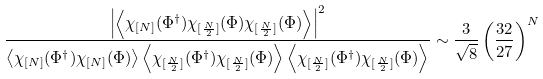<formula> <loc_0><loc_0><loc_500><loc_500>\frac { \left | \left \langle \chi _ { [ N ] } ( \Phi ^ { \dagger } ) \chi _ { [ \frac { N } { 2 } ] } ( \Phi ) \chi _ { [ \frac { N } { 2 } ] } ( \Phi ) \right \rangle \right | ^ { 2 } } { \left \langle \chi _ { [ N ] } ( \Phi ^ { \dagger } ) \chi _ { [ N ] } ( \Phi ) \right \rangle \left \langle \chi _ { [ \frac { N } { 2 } ] } ( \Phi ^ { \dagger } ) \chi _ { [ \frac { N } { 2 } ] } ( \Phi ) \right \rangle \left \langle \chi _ { [ \frac { N } { 2 } ] } ( \Phi ^ { \dagger } ) \chi _ { [ \frac { N } { 2 } ] } ( \Phi ) \right \rangle } \sim \frac { 3 } { \sqrt { 8 } } \left ( \frac { 3 2 } { 2 7 } \right ) ^ { N }</formula> 